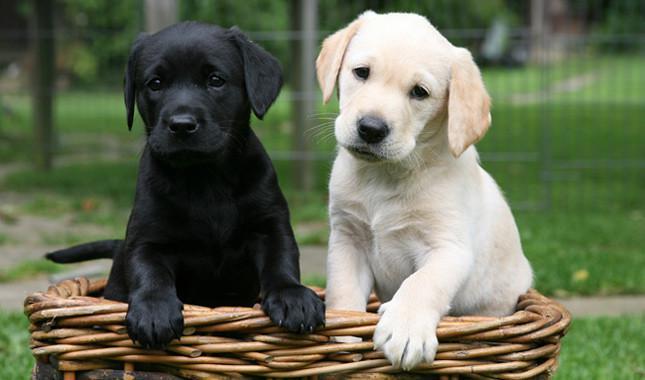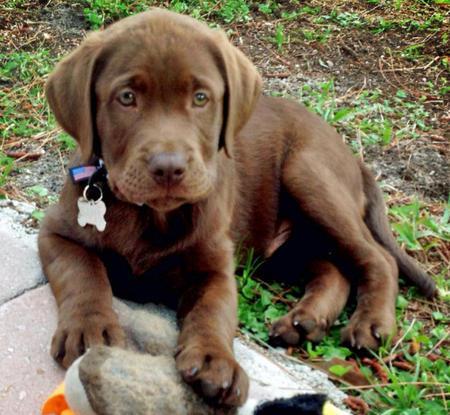The first image is the image on the left, the second image is the image on the right. Examine the images to the left and right. Is the description "One image shows side-by-side puppies posed with front paws dangling over an edge, and the other image shows one blond pup in position to lick the blond pup next to it." accurate? Answer yes or no. No. The first image is the image on the left, the second image is the image on the right. Examine the images to the left and right. Is the description "The two dogs in one of the images are sitting in a container." accurate? Answer yes or no. Yes. 